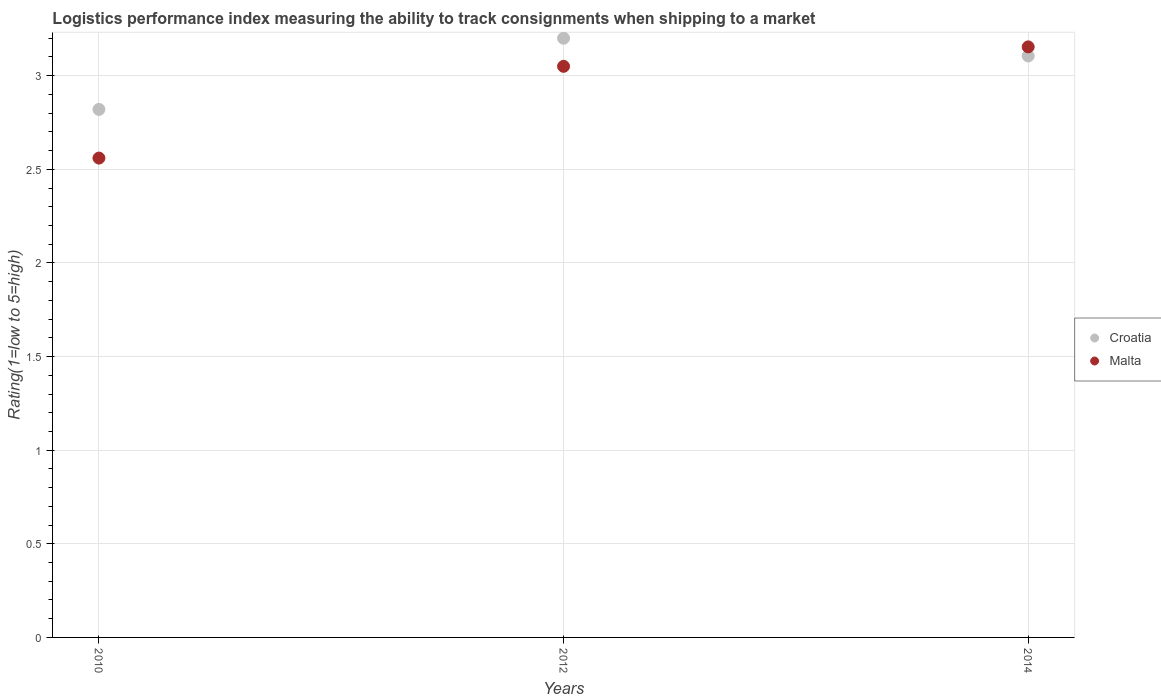Is the number of dotlines equal to the number of legend labels?
Your response must be concise. Yes. What is the Logistic performance index in Croatia in 2010?
Your answer should be compact. 2.82. Across all years, what is the maximum Logistic performance index in Croatia?
Your answer should be very brief. 3.2. Across all years, what is the minimum Logistic performance index in Malta?
Provide a short and direct response. 2.56. In which year was the Logistic performance index in Malta maximum?
Provide a succinct answer. 2014. In which year was the Logistic performance index in Croatia minimum?
Give a very brief answer. 2010. What is the total Logistic performance index in Croatia in the graph?
Provide a short and direct response. 9.13. What is the difference between the Logistic performance index in Malta in 2010 and that in 2012?
Provide a short and direct response. -0.49. What is the difference between the Logistic performance index in Croatia in 2014 and the Logistic performance index in Malta in 2010?
Your answer should be compact. 0.55. What is the average Logistic performance index in Malta per year?
Provide a short and direct response. 2.92. In the year 2010, what is the difference between the Logistic performance index in Croatia and Logistic performance index in Malta?
Your answer should be very brief. 0.26. What is the ratio of the Logistic performance index in Croatia in 2010 to that in 2014?
Keep it short and to the point. 0.91. Is the Logistic performance index in Malta in 2010 less than that in 2014?
Make the answer very short. Yes. What is the difference between the highest and the second highest Logistic performance index in Malta?
Your answer should be very brief. 0.1. What is the difference between the highest and the lowest Logistic performance index in Croatia?
Ensure brevity in your answer.  0.38. In how many years, is the Logistic performance index in Malta greater than the average Logistic performance index in Malta taken over all years?
Provide a succinct answer. 2. Is the Logistic performance index in Croatia strictly greater than the Logistic performance index in Malta over the years?
Provide a short and direct response. No. Is the Logistic performance index in Malta strictly less than the Logistic performance index in Croatia over the years?
Your response must be concise. No. What is the difference between two consecutive major ticks on the Y-axis?
Ensure brevity in your answer.  0.5. How many legend labels are there?
Provide a short and direct response. 2. How are the legend labels stacked?
Give a very brief answer. Vertical. What is the title of the graph?
Your response must be concise. Logistics performance index measuring the ability to track consignments when shipping to a market. What is the label or title of the Y-axis?
Provide a succinct answer. Rating(1=low to 5=high). What is the Rating(1=low to 5=high) of Croatia in 2010?
Provide a short and direct response. 2.82. What is the Rating(1=low to 5=high) of Malta in 2010?
Provide a short and direct response. 2.56. What is the Rating(1=low to 5=high) of Croatia in 2012?
Make the answer very short. 3.2. What is the Rating(1=low to 5=high) in Malta in 2012?
Provide a short and direct response. 3.05. What is the Rating(1=low to 5=high) of Croatia in 2014?
Give a very brief answer. 3.11. What is the Rating(1=low to 5=high) of Malta in 2014?
Your answer should be compact. 3.15. Across all years, what is the maximum Rating(1=low to 5=high) in Croatia?
Your answer should be compact. 3.2. Across all years, what is the maximum Rating(1=low to 5=high) in Malta?
Your answer should be compact. 3.15. Across all years, what is the minimum Rating(1=low to 5=high) of Croatia?
Your answer should be very brief. 2.82. Across all years, what is the minimum Rating(1=low to 5=high) of Malta?
Give a very brief answer. 2.56. What is the total Rating(1=low to 5=high) of Croatia in the graph?
Ensure brevity in your answer.  9.13. What is the total Rating(1=low to 5=high) in Malta in the graph?
Offer a terse response. 8.76. What is the difference between the Rating(1=low to 5=high) in Croatia in 2010 and that in 2012?
Give a very brief answer. -0.38. What is the difference between the Rating(1=low to 5=high) of Malta in 2010 and that in 2012?
Keep it short and to the point. -0.49. What is the difference between the Rating(1=low to 5=high) in Croatia in 2010 and that in 2014?
Keep it short and to the point. -0.29. What is the difference between the Rating(1=low to 5=high) in Malta in 2010 and that in 2014?
Provide a succinct answer. -0.59. What is the difference between the Rating(1=low to 5=high) in Croatia in 2012 and that in 2014?
Offer a terse response. 0.09. What is the difference between the Rating(1=low to 5=high) in Malta in 2012 and that in 2014?
Offer a terse response. -0.1. What is the difference between the Rating(1=low to 5=high) of Croatia in 2010 and the Rating(1=low to 5=high) of Malta in 2012?
Give a very brief answer. -0.23. What is the difference between the Rating(1=low to 5=high) of Croatia in 2010 and the Rating(1=low to 5=high) of Malta in 2014?
Give a very brief answer. -0.33. What is the difference between the Rating(1=low to 5=high) in Croatia in 2012 and the Rating(1=low to 5=high) in Malta in 2014?
Offer a very short reply. 0.05. What is the average Rating(1=low to 5=high) in Croatia per year?
Provide a succinct answer. 3.04. What is the average Rating(1=low to 5=high) of Malta per year?
Offer a very short reply. 2.92. In the year 2010, what is the difference between the Rating(1=low to 5=high) in Croatia and Rating(1=low to 5=high) in Malta?
Make the answer very short. 0.26. In the year 2014, what is the difference between the Rating(1=low to 5=high) of Croatia and Rating(1=low to 5=high) of Malta?
Make the answer very short. -0.05. What is the ratio of the Rating(1=low to 5=high) in Croatia in 2010 to that in 2012?
Your answer should be compact. 0.88. What is the ratio of the Rating(1=low to 5=high) of Malta in 2010 to that in 2012?
Make the answer very short. 0.84. What is the ratio of the Rating(1=low to 5=high) of Croatia in 2010 to that in 2014?
Your response must be concise. 0.91. What is the ratio of the Rating(1=low to 5=high) in Malta in 2010 to that in 2014?
Keep it short and to the point. 0.81. What is the ratio of the Rating(1=low to 5=high) of Croatia in 2012 to that in 2014?
Offer a terse response. 1.03. What is the ratio of the Rating(1=low to 5=high) of Malta in 2012 to that in 2014?
Provide a short and direct response. 0.97. What is the difference between the highest and the second highest Rating(1=low to 5=high) of Croatia?
Make the answer very short. 0.09. What is the difference between the highest and the second highest Rating(1=low to 5=high) of Malta?
Keep it short and to the point. 0.1. What is the difference between the highest and the lowest Rating(1=low to 5=high) in Croatia?
Your answer should be very brief. 0.38. What is the difference between the highest and the lowest Rating(1=low to 5=high) in Malta?
Keep it short and to the point. 0.59. 